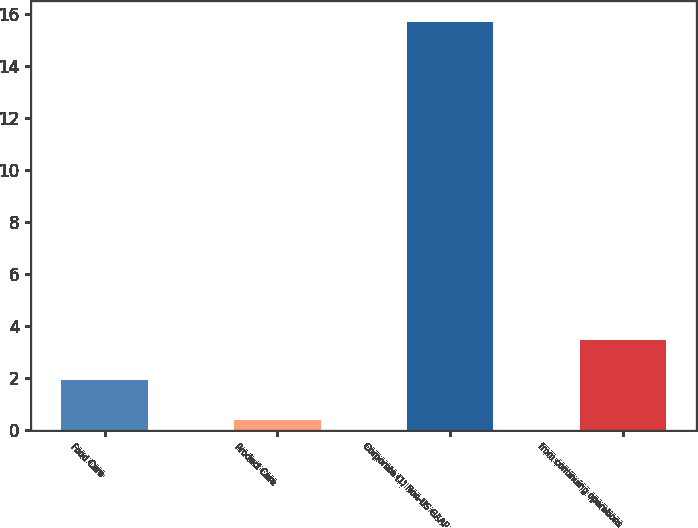<chart> <loc_0><loc_0><loc_500><loc_500><bar_chart><fcel>Food Care<fcel>Product Care<fcel>Corporate (1) Non-US GAAP<fcel>from continuing operations<nl><fcel>1.93<fcel>0.4<fcel>15.7<fcel>3.46<nl></chart> 